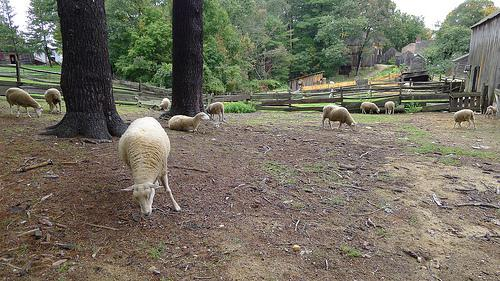Question: what animals are these?
Choices:
A. Moose.
B. Bears.
C. Sheep.
D. Mice.
Answer with the letter. Answer: C Question: what material is the fencing?
Choices:
A. Metal.
B. Vinyl.
C. Brick.
D. Wooden.
Answer with the letter. Answer: D Question: what color is the ground?
Choices:
A. Black.
B. Brown.
C. Yellow.
D. White.
Answer with the letter. Answer: B Question: what color are the trees?
Choices:
A. Brown.
B. Green.
C. Yellow.
D. Black.
Answer with the letter. Answer: B Question: what color is the barn?
Choices:
A. Red.
B. Orange.
C. Yellow.
D. Gray.
Answer with the letter. Answer: D 